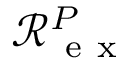Convert formula to latex. <formula><loc_0><loc_0><loc_500><loc_500>\mathcal { R } _ { e x } ^ { P }</formula> 